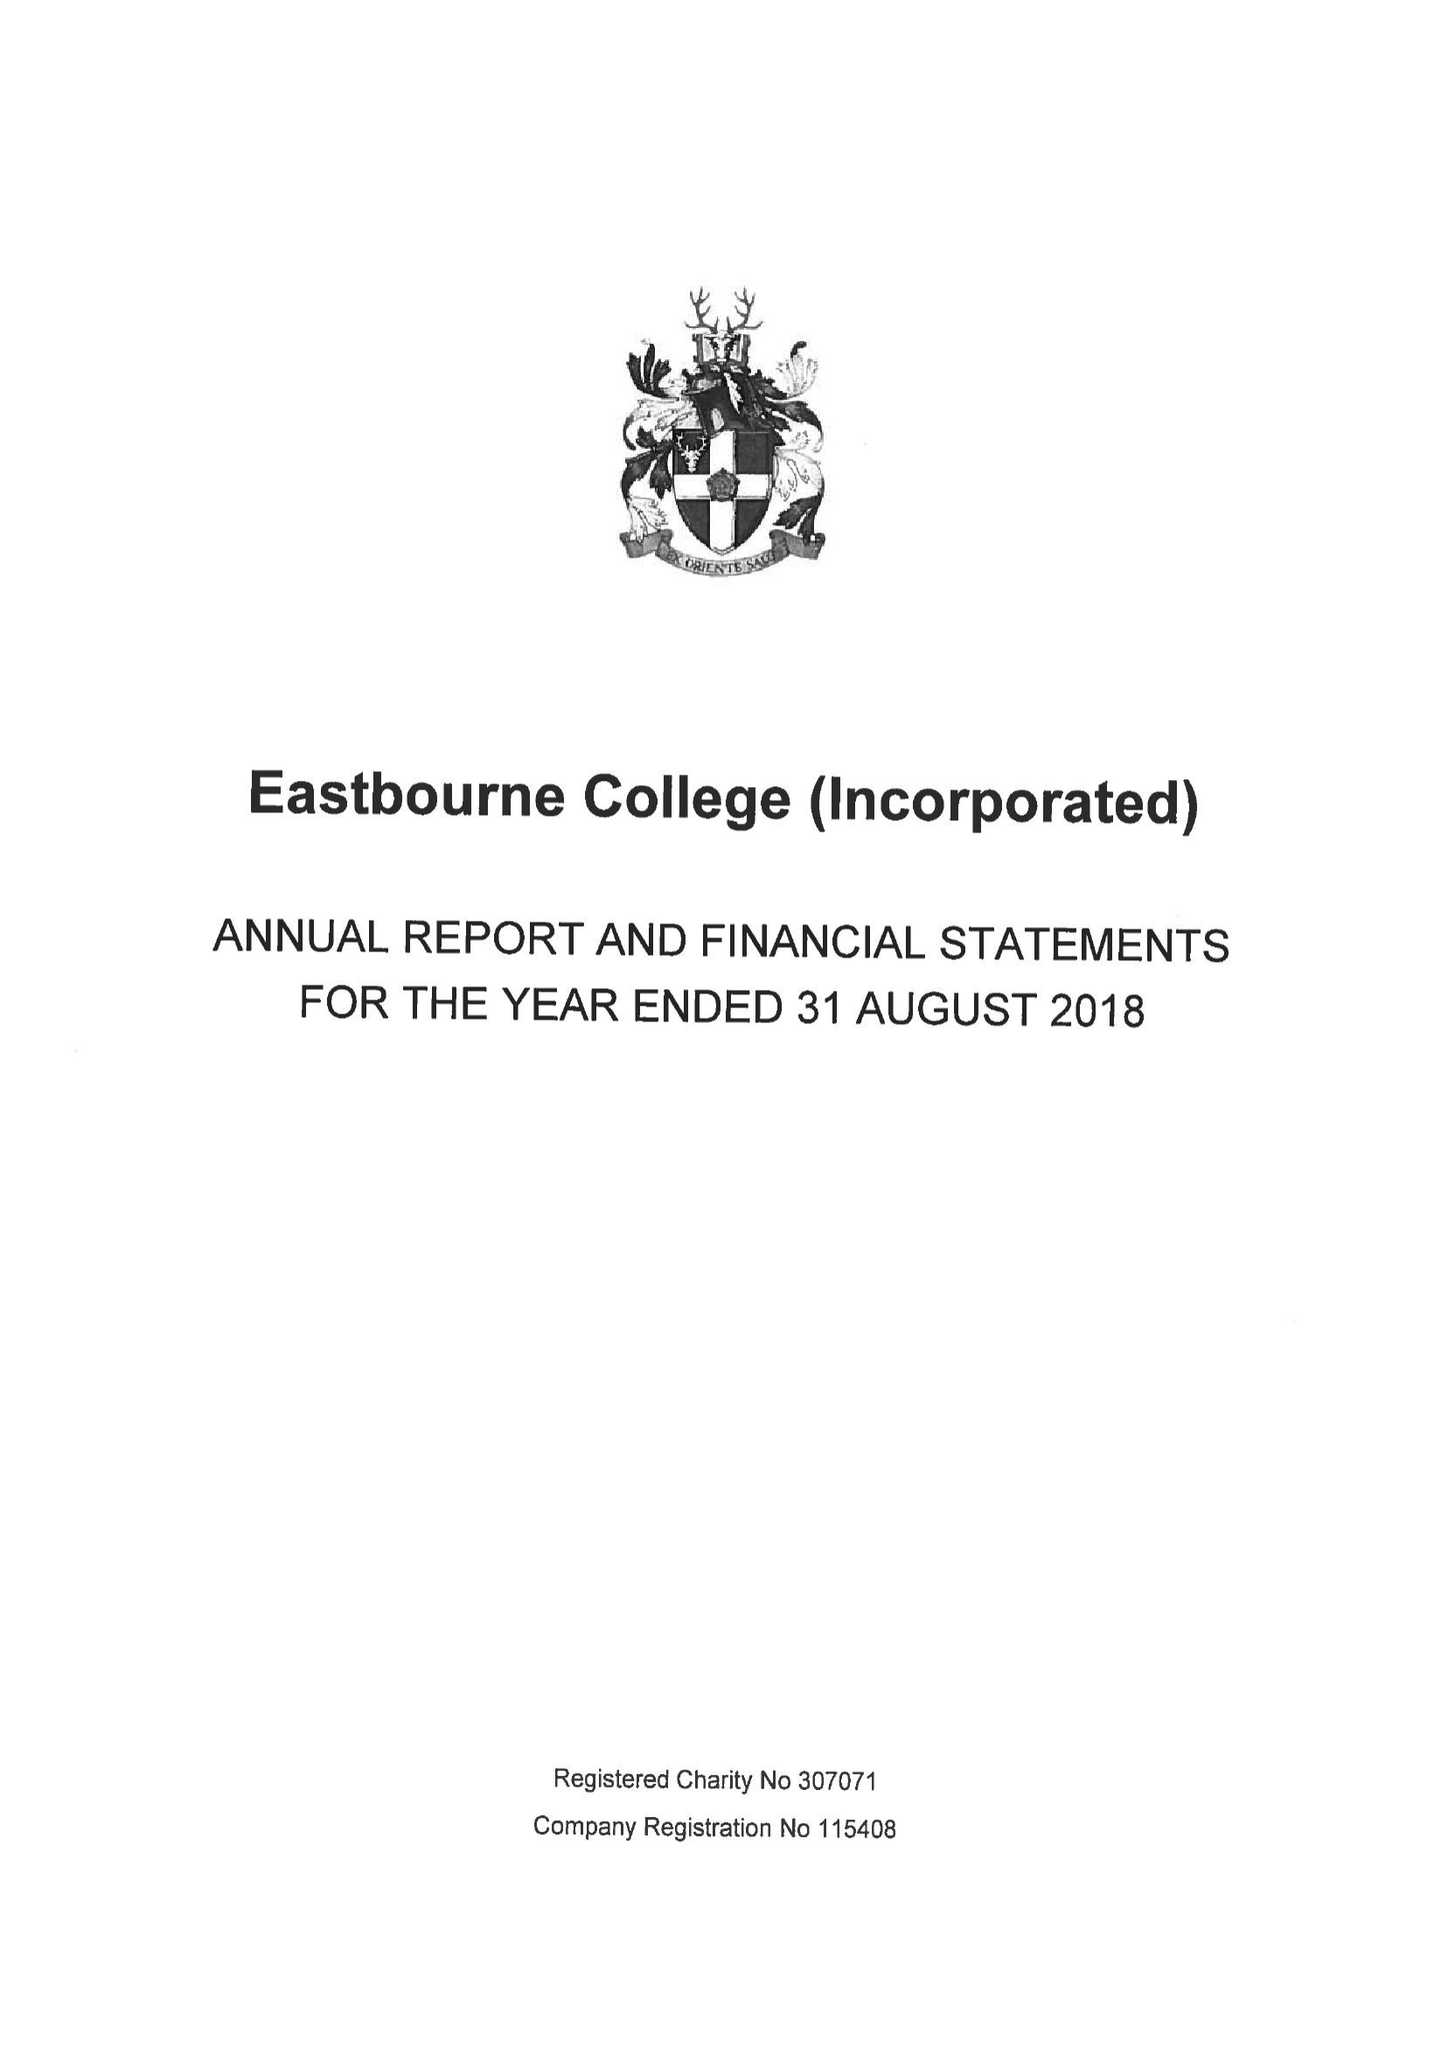What is the value for the charity_number?
Answer the question using a single word or phrase. 307071 